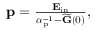<formula> <loc_0><loc_0><loc_500><loc_500>\begin{array} { r } { \mathbf p = \frac { \mathbf E _ { i n } } { \boldsymbol \alpha _ { p } ^ { - 1 } - \widetilde { \mathbf G } ( 0 ) } , } \end{array}</formula> 